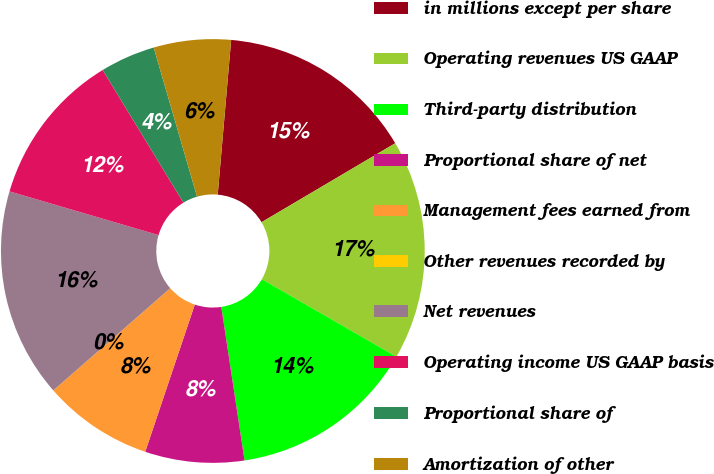Convert chart. <chart><loc_0><loc_0><loc_500><loc_500><pie_chart><fcel>in millions except per share<fcel>Operating revenues US GAAP<fcel>Third-party distribution<fcel>Proportional share of net<fcel>Management fees earned from<fcel>Other revenues recorded by<fcel>Net revenues<fcel>Operating income US GAAP basis<fcel>Proportional share of<fcel>Amortization of other<nl><fcel>15.13%<fcel>16.81%<fcel>14.29%<fcel>7.56%<fcel>8.4%<fcel>0.0%<fcel>15.97%<fcel>11.76%<fcel>4.2%<fcel>5.88%<nl></chart> 